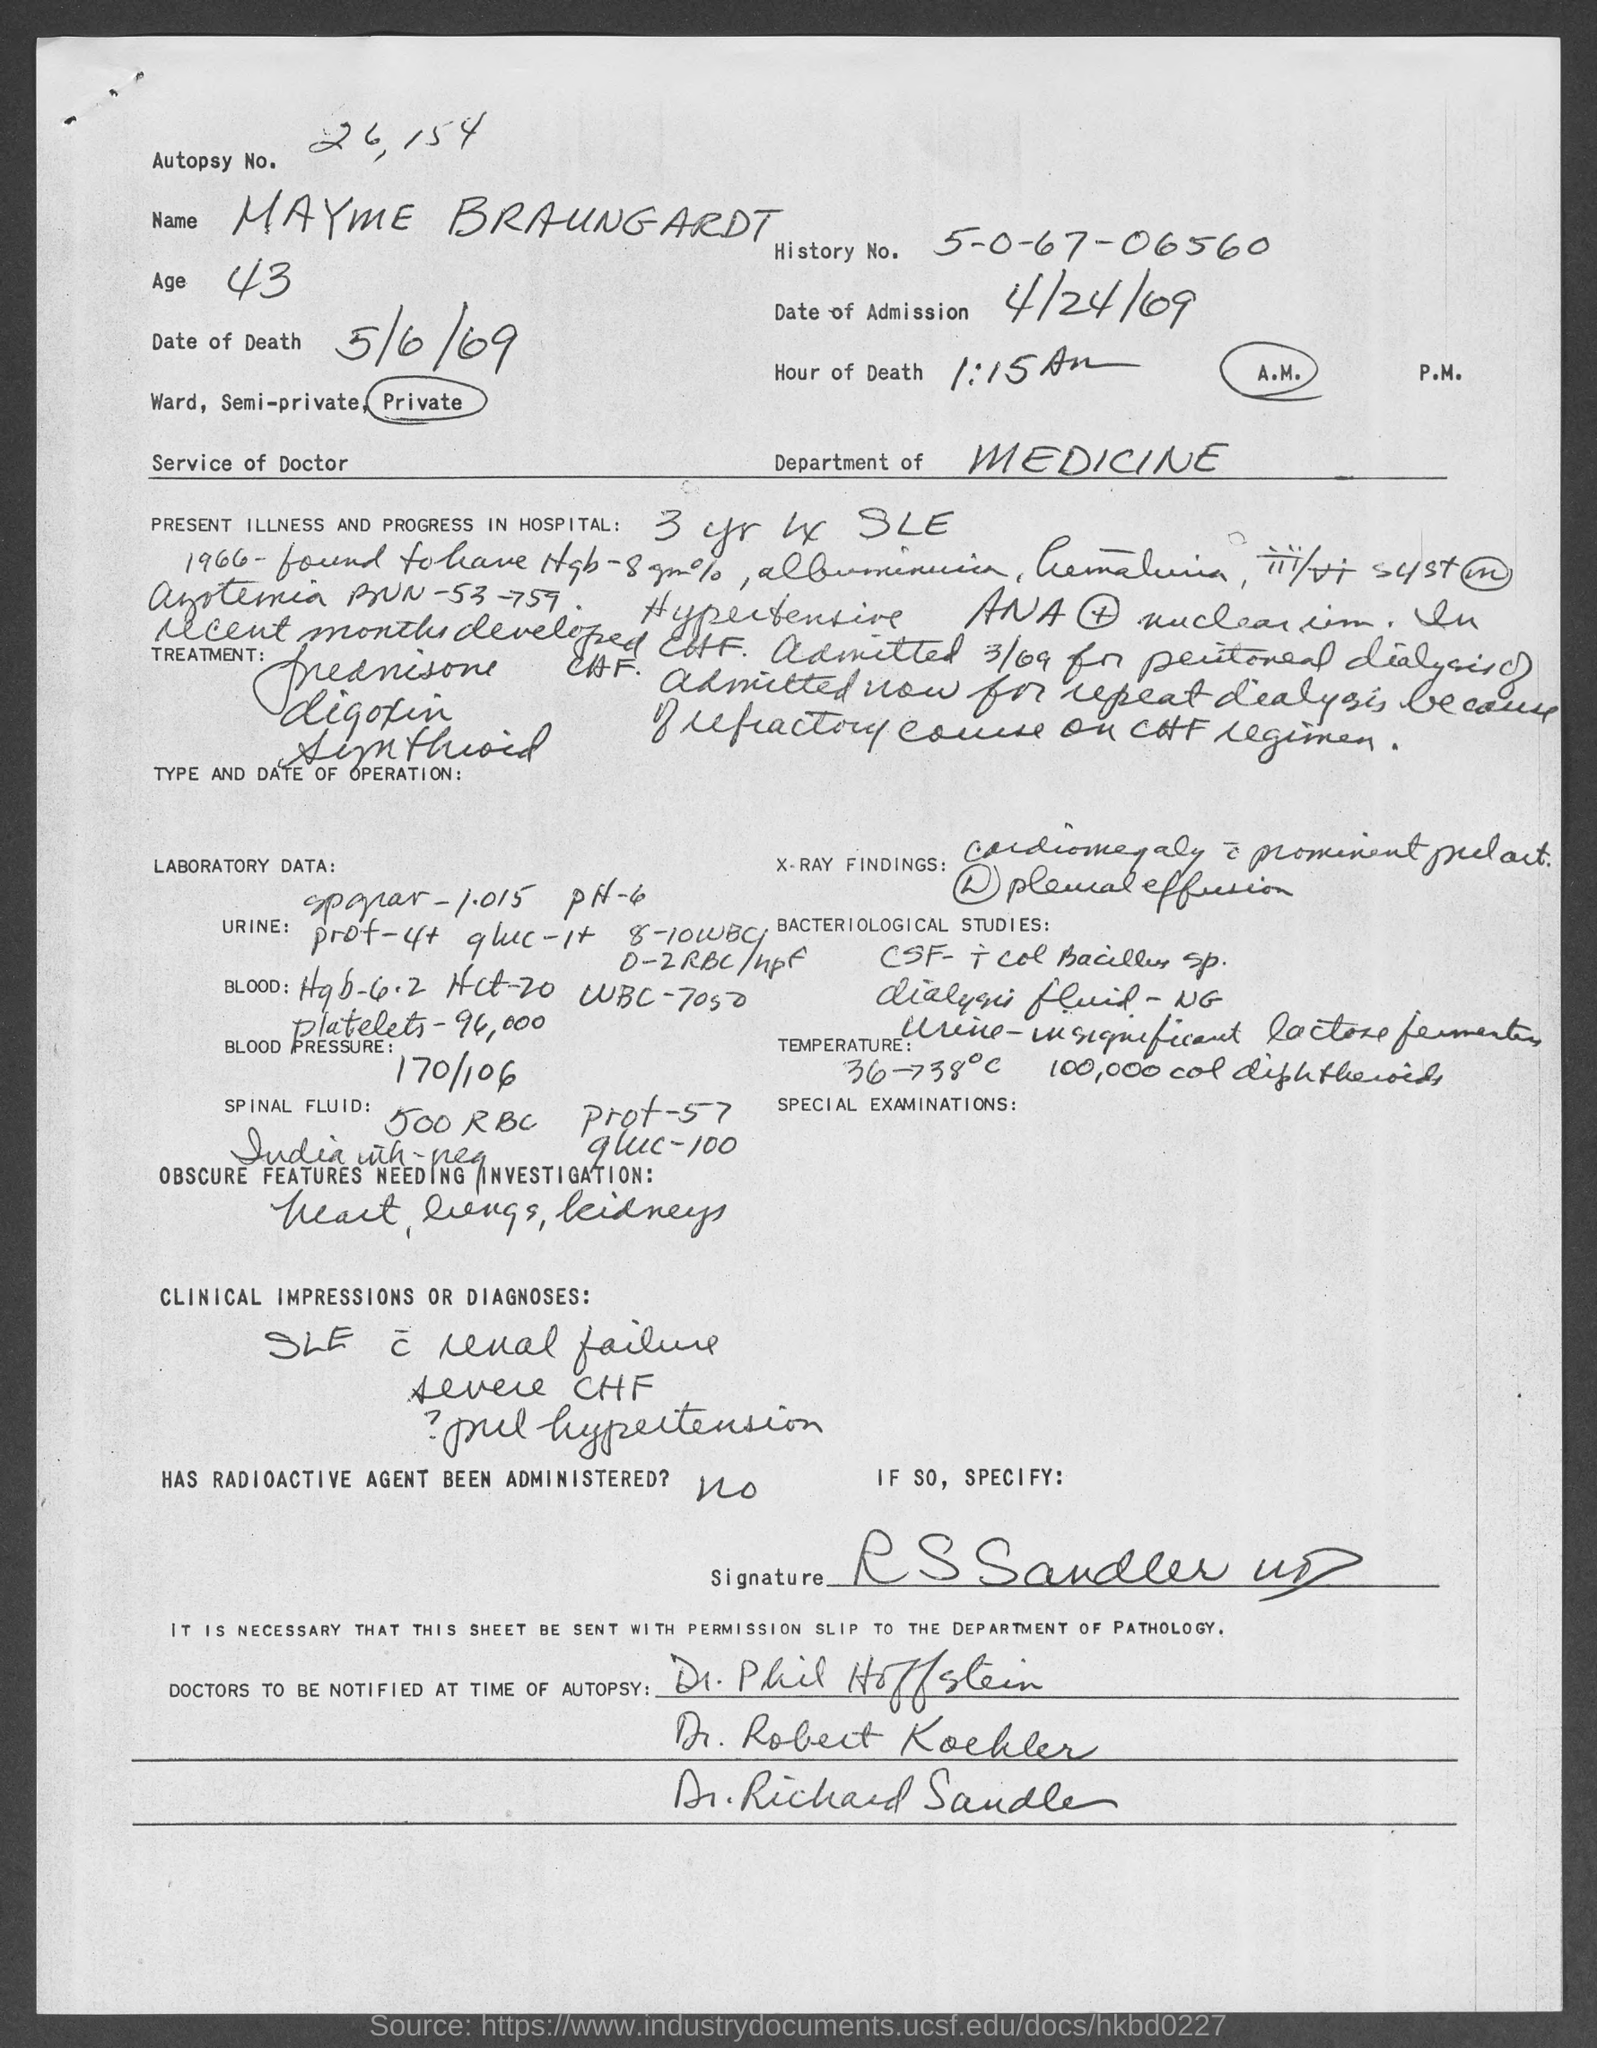Point out several critical features in this image. At 1:15 A.M., the hour of death is? Mayme Braungardt is 43 years old. The name of the person mentioned at the top of the document is Mayme Braungardt. The date of death is May 6, 1969. The date of admission is April 24, 1969. 